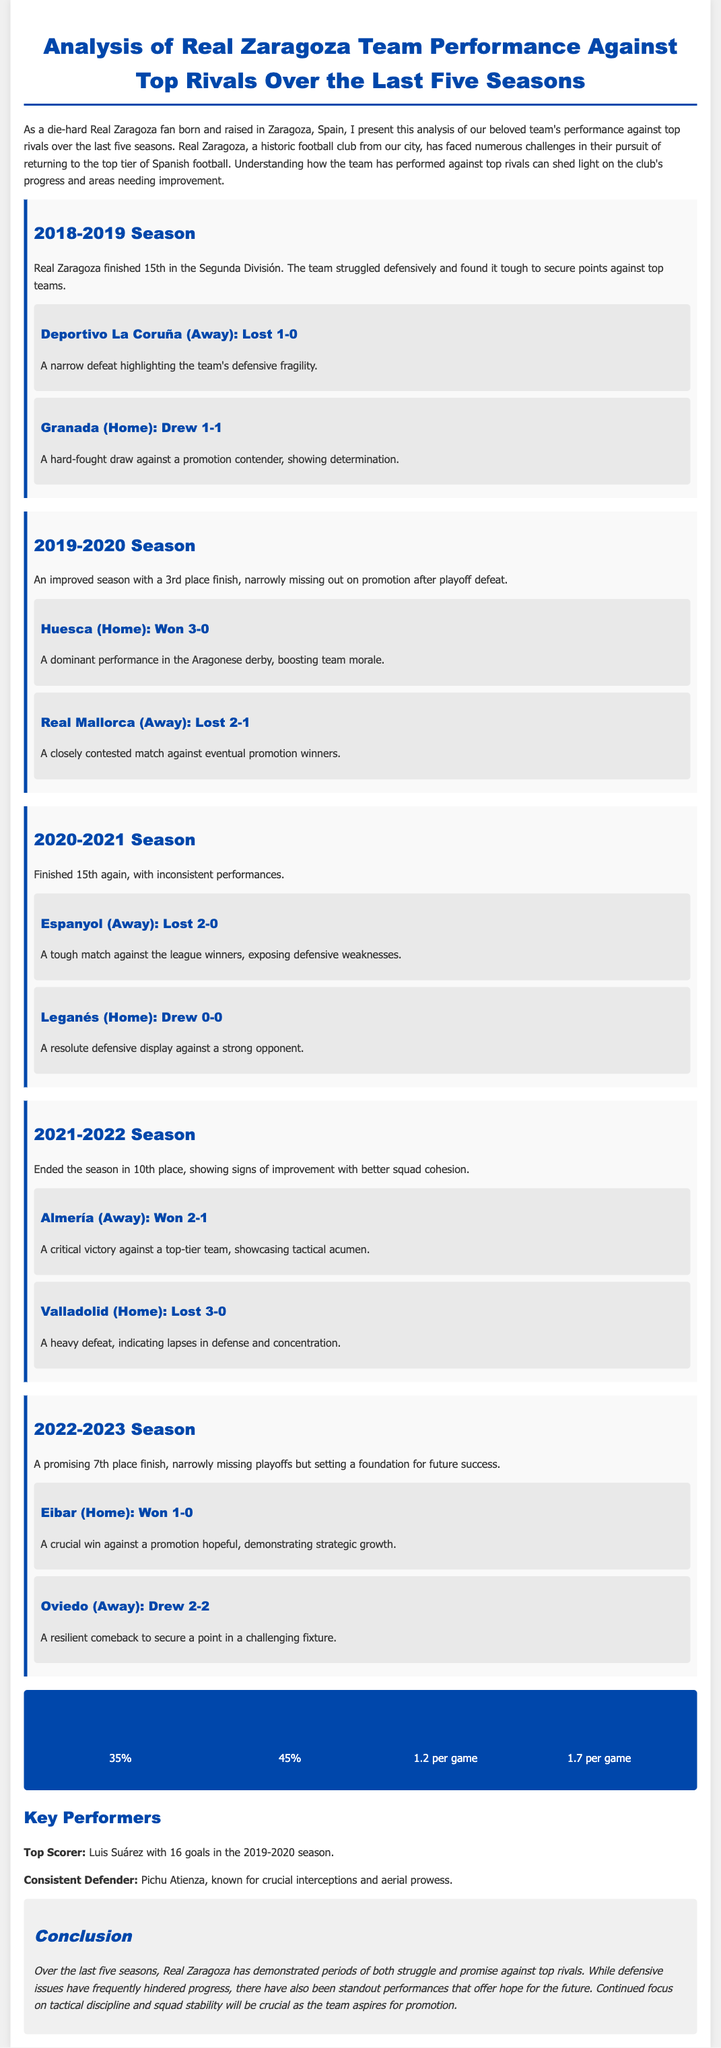what was Real Zaragoza's finish in the 2018-2019 season? The 2018-2019 season saw Real Zaragoza finish 15th in the Segunda División.
Answer: 15th who was the top scorer for Real Zaragoza in the 2019-2020 season? The document states that Luis Suárez was the top scorer with 16 goals in the 2019-2020 season.
Answer: Luis Suárez what is the average goals for Real Zaragoza per game against top rivals? According to the statistics, Real Zaragoza averages 1.2 goals for per game against top rivals.
Answer: 1.2 how did Real Zaragoza perform against Huesca in the 2019-2020 season? The analysis mentions that Real Zaragoza won 3-0 against Huesca, indicating a dominant performance.
Answer: Won 3-0 what was the win ratio of Real Zaragoza against the top 6 teams? The document indicates that the win ratio against the top 6 teams is 35%.
Answer: 35% what defensive issue did Real Zaragoza face during the 2020-2021 season? The document notes that the team struggled with defensive weaknesses, especially highlighted in the match against Espanyol.
Answer: Defensive weaknesses which season did Real Zaragoza show the most improvement in terms of league position? The 2022-2023 season marked a promising 7th place finish, indicating improvement.
Answer: 2022-2023 what was the conclusion about Real Zaragoza's performance in the last five seasons? The conclusion states there were both struggles and promises, with a focus on tactical discipline and squad stability needed for future success.
Answer: Struggles and promises 